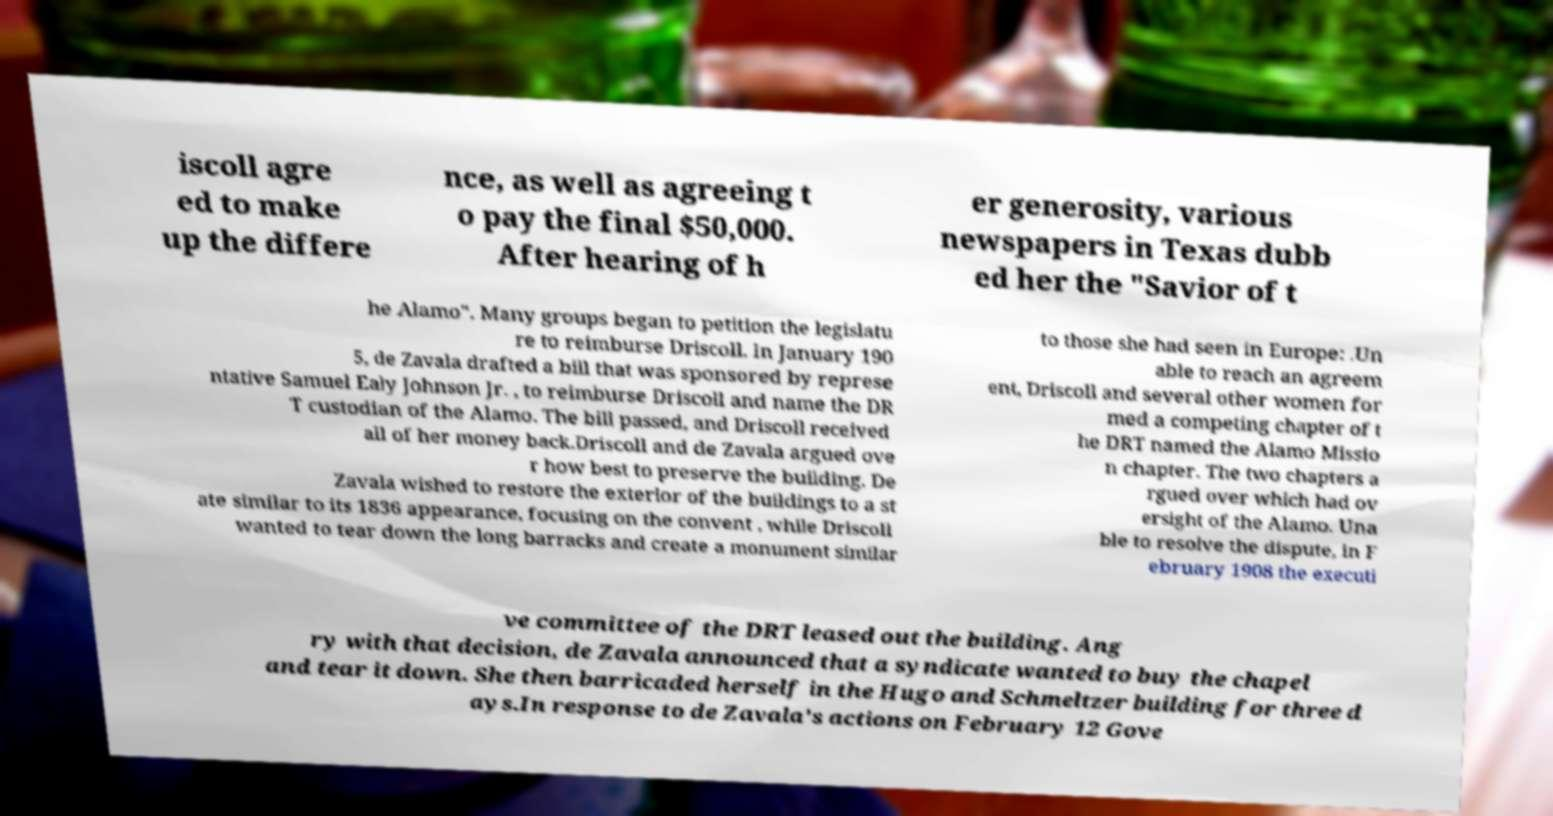What messages or text are displayed in this image? I need them in a readable, typed format. iscoll agre ed to make up the differe nce, as well as agreeing t o pay the final $50,000. After hearing of h er generosity, various newspapers in Texas dubb ed her the "Savior of t he Alamo". Many groups began to petition the legislatu re to reimburse Driscoll. In January 190 5, de Zavala drafted a bill that was sponsored by represe ntative Samuel Ealy Johnson Jr. , to reimburse Driscoll and name the DR T custodian of the Alamo. The bill passed, and Driscoll received all of her money back.Driscoll and de Zavala argued ove r how best to preserve the building. De Zavala wished to restore the exterior of the buildings to a st ate similar to its 1836 appearance, focusing on the convent , while Driscoll wanted to tear down the long barracks and create a monument similar to those she had seen in Europe: .Un able to reach an agreem ent, Driscoll and several other women for med a competing chapter of t he DRT named the Alamo Missio n chapter. The two chapters a rgued over which had ov ersight of the Alamo. Una ble to resolve the dispute, in F ebruary 1908 the executi ve committee of the DRT leased out the building. Ang ry with that decision, de Zavala announced that a syndicate wanted to buy the chapel and tear it down. She then barricaded herself in the Hugo and Schmeltzer building for three d ays.In response to de Zavala's actions on February 12 Gove 